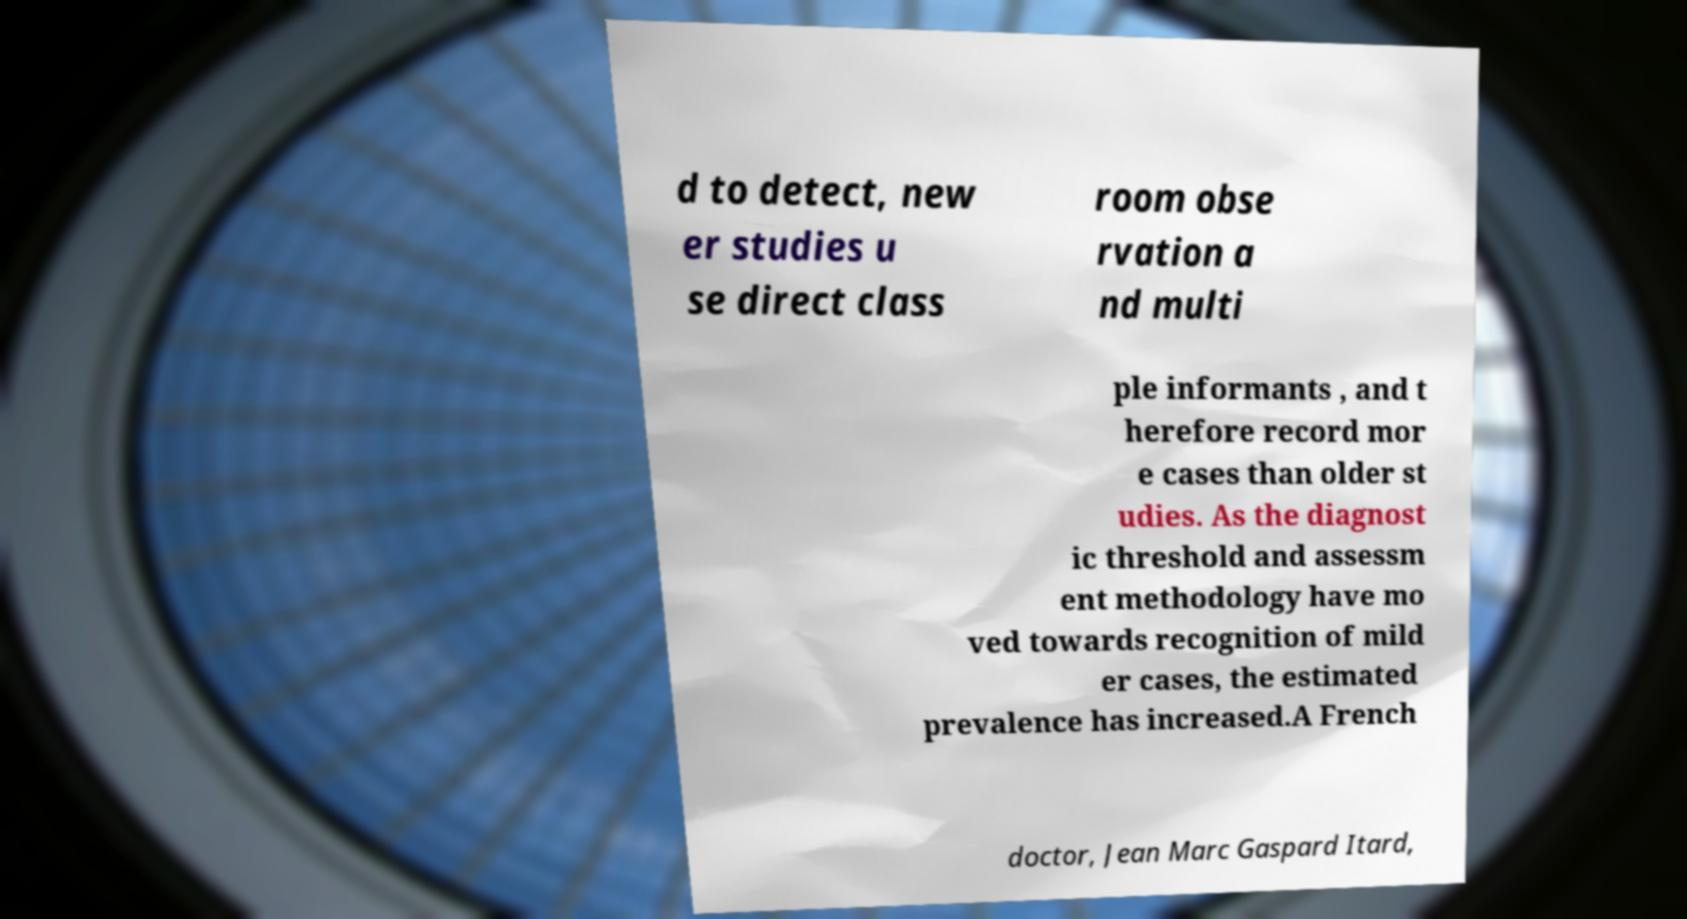Please read and relay the text visible in this image. What does it say? d to detect, new er studies u se direct class room obse rvation a nd multi ple informants , and t herefore record mor e cases than older st udies. As the diagnost ic threshold and assessm ent methodology have mo ved towards recognition of mild er cases, the estimated prevalence has increased.A French doctor, Jean Marc Gaspard Itard, 